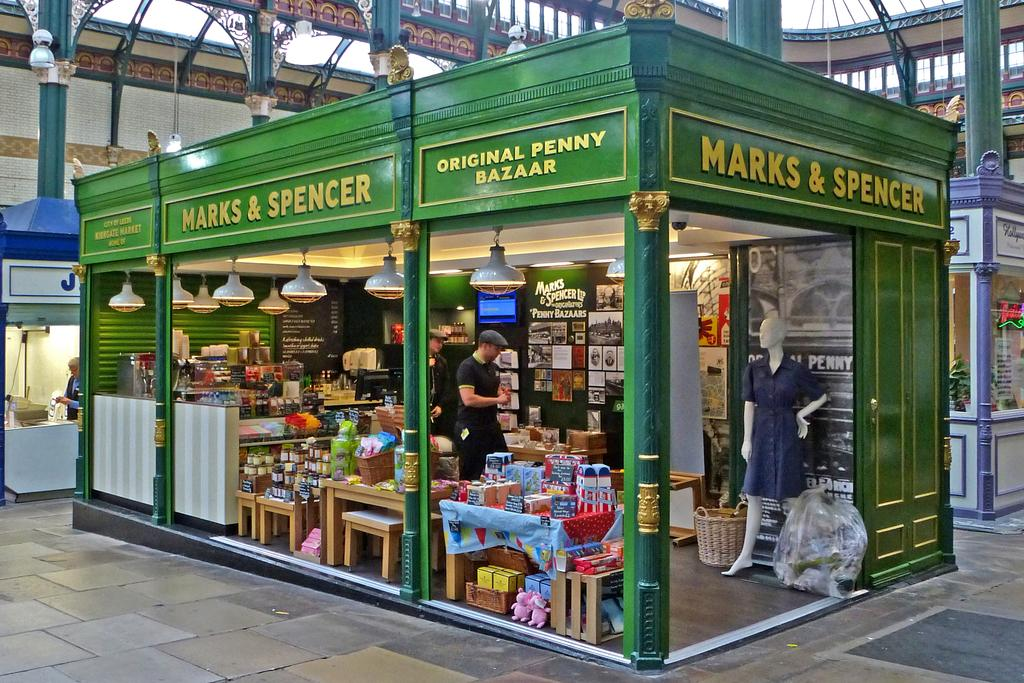<image>
Write a terse but informative summary of the picture. A very old fashioned looking branch of Marks and Spencer 